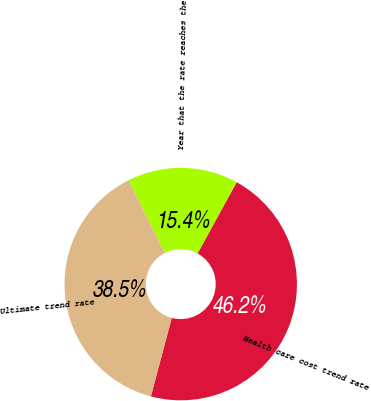<chart> <loc_0><loc_0><loc_500><loc_500><pie_chart><fcel>Health care cost trend rate<fcel>Ultimate trend rate<fcel>Year that the rate reaches the<nl><fcel>46.15%<fcel>38.46%<fcel>15.38%<nl></chart> 